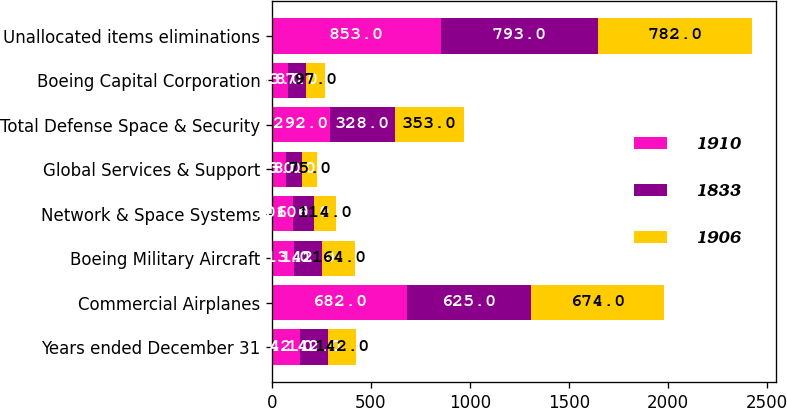<chart> <loc_0><loc_0><loc_500><loc_500><stacked_bar_chart><ecel><fcel>Years ended December 31<fcel>Commercial Airplanes<fcel>Boeing Military Aircraft<fcel>Network & Space Systems<fcel>Global Services & Support<fcel>Total Defense Space & Security<fcel>Boeing Capital Corporation<fcel>Unallocated items eliminations<nl><fcel>1910<fcel>142<fcel>682<fcel>113<fcel>106<fcel>73<fcel>292<fcel>83<fcel>853<nl><fcel>1833<fcel>142<fcel>625<fcel>142<fcel>106<fcel>80<fcel>328<fcel>87<fcel>793<nl><fcel>1906<fcel>142<fcel>674<fcel>164<fcel>114<fcel>75<fcel>353<fcel>97<fcel>782<nl></chart> 